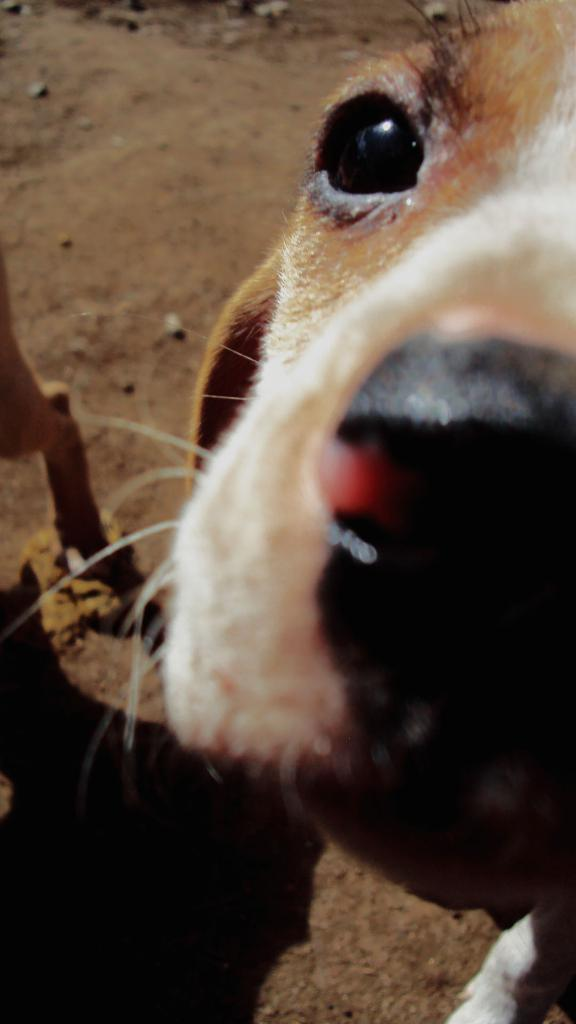How many dogs are present in the image? There are two dogs in the image. What is the surface that the dogs are on? Both dogs are on a surface of sand. What type of nerve is visible in the image? There is no nerve visible in the image; it features two dogs on a sandy surface. How many brothers are present in the image? There is no mention of brothers in the image; it features two dogs. 